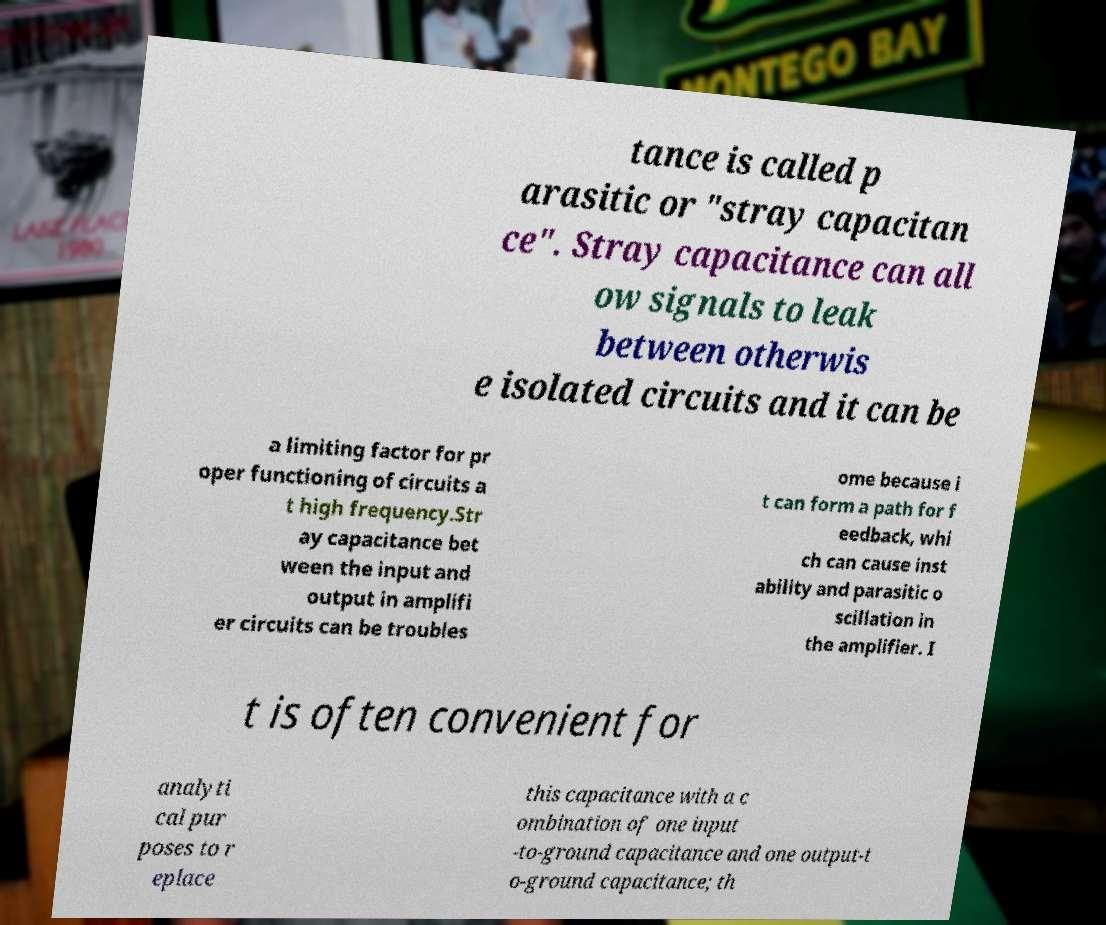What messages or text are displayed in this image? I need them in a readable, typed format. tance is called p arasitic or "stray capacitan ce". Stray capacitance can all ow signals to leak between otherwis e isolated circuits and it can be a limiting factor for pr oper functioning of circuits a t high frequency.Str ay capacitance bet ween the input and output in amplifi er circuits can be troubles ome because i t can form a path for f eedback, whi ch can cause inst ability and parasitic o scillation in the amplifier. I t is often convenient for analyti cal pur poses to r eplace this capacitance with a c ombination of one input -to-ground capacitance and one output-t o-ground capacitance; th 